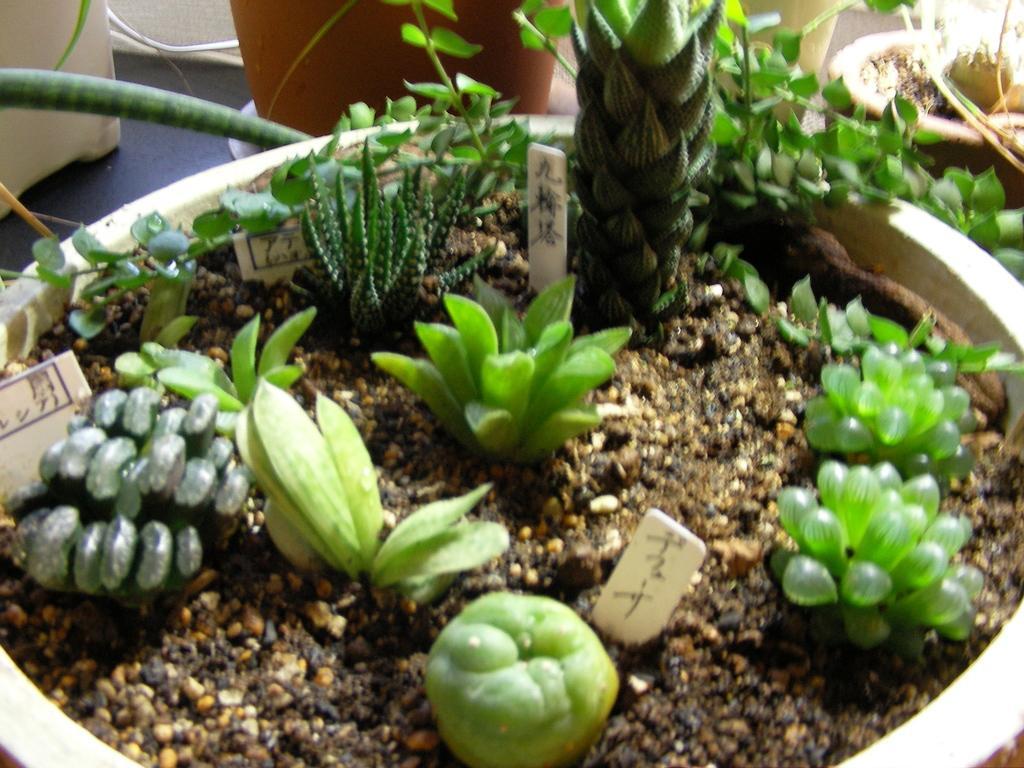Can you describe this image briefly? In this picture we can see flower pots on the floor, plants and boards. 